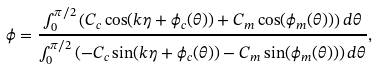<formula> <loc_0><loc_0><loc_500><loc_500>\phi = \frac { \int _ { 0 } ^ { \pi / 2 } \left ( C _ { c } \cos ( k \eta + \phi _ { c } ( \theta ) ) + C _ { m } \cos ( \phi _ { m } ( \theta ) ) \right ) d \theta } { \int _ { 0 } ^ { \pi / 2 } \left ( - C _ { c } \sin ( k \eta + \phi _ { c } ( \theta ) ) - C _ { m } \sin ( \phi _ { m } ( \theta ) ) \right ) d \theta } ,</formula> 